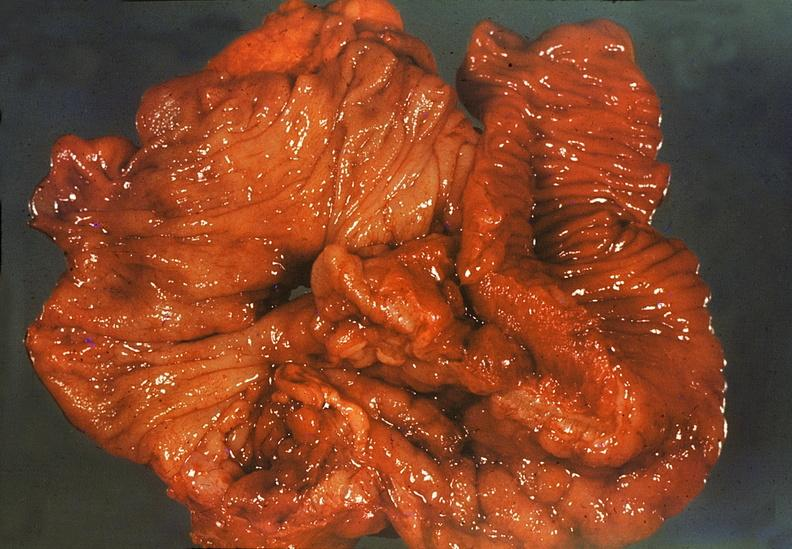where does this belong to?
Answer the question using a single word or phrase. Gastrointestinal system 